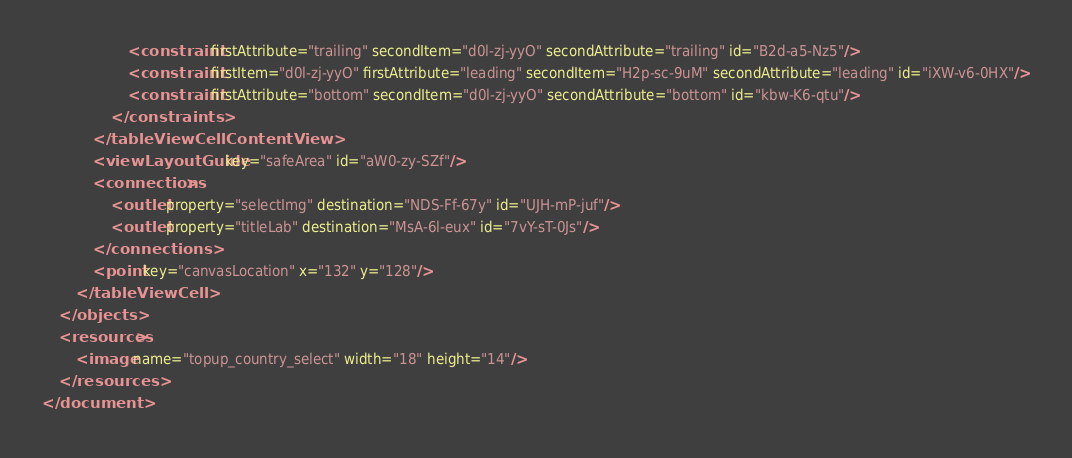Convert code to text. <code><loc_0><loc_0><loc_500><loc_500><_XML_>                    <constraint firstAttribute="trailing" secondItem="d0l-zj-yyO" secondAttribute="trailing" id="B2d-a5-Nz5"/>
                    <constraint firstItem="d0l-zj-yyO" firstAttribute="leading" secondItem="H2p-sc-9uM" secondAttribute="leading" id="iXW-v6-0HX"/>
                    <constraint firstAttribute="bottom" secondItem="d0l-zj-yyO" secondAttribute="bottom" id="kbw-K6-qtu"/>
                </constraints>
            </tableViewCellContentView>
            <viewLayoutGuide key="safeArea" id="aW0-zy-SZf"/>
            <connections>
                <outlet property="selectImg" destination="NDS-Ff-67y" id="UJH-mP-juf"/>
                <outlet property="titleLab" destination="MsA-6l-eux" id="7vY-sT-0Js"/>
            </connections>
            <point key="canvasLocation" x="132" y="128"/>
        </tableViewCell>
    </objects>
    <resources>
        <image name="topup_country_select" width="18" height="14"/>
    </resources>
</document>
</code> 